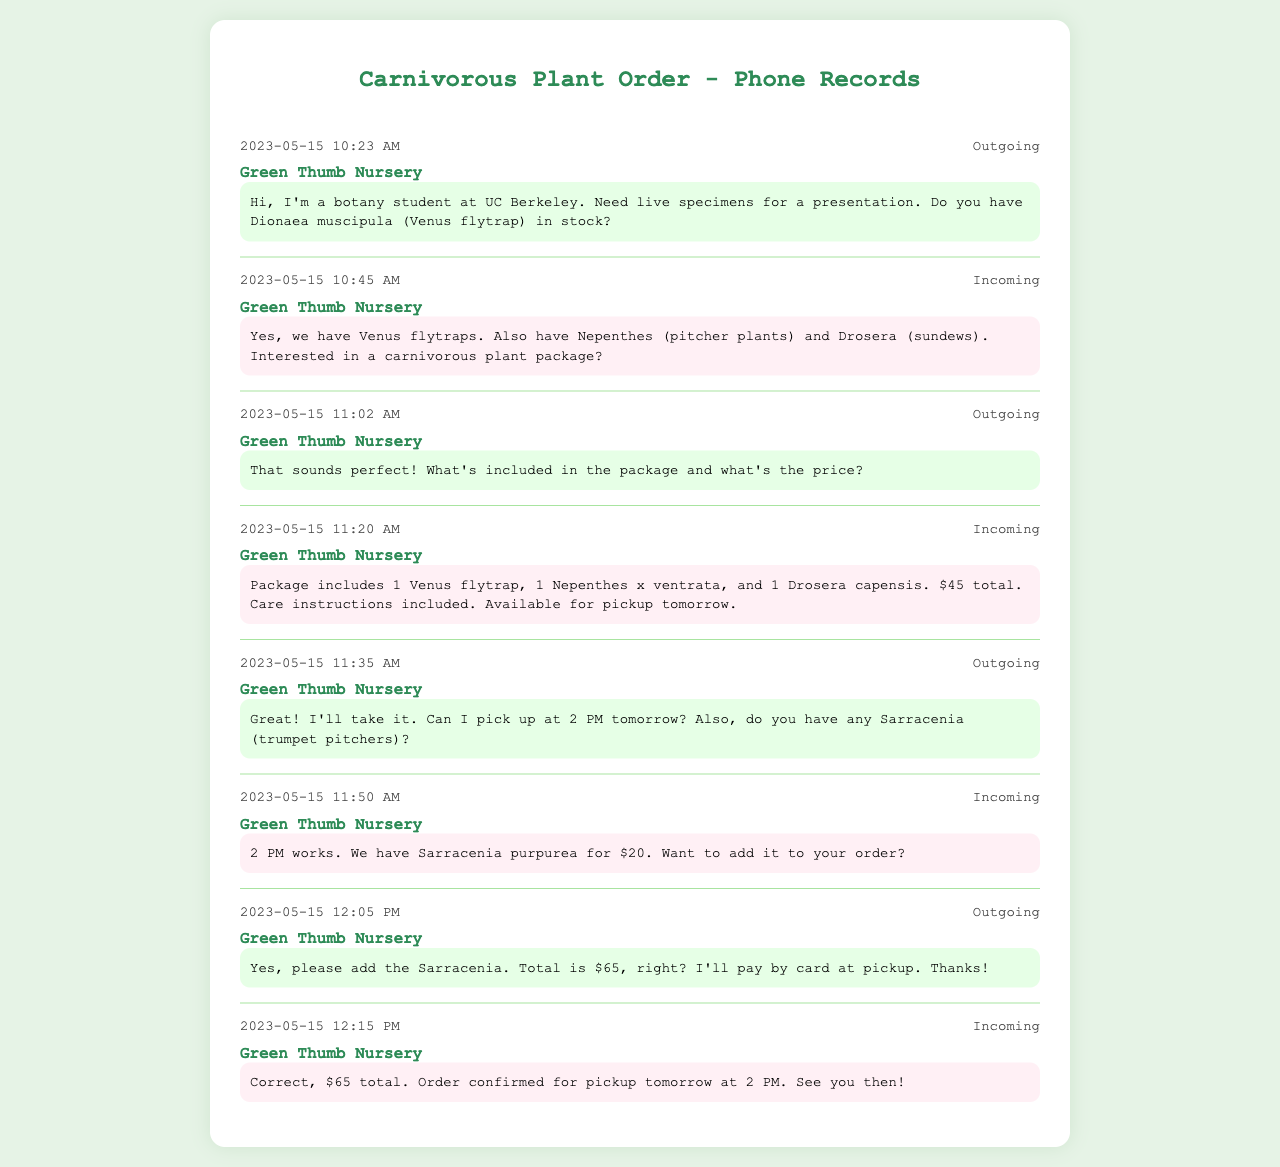what is the date of the order? The date of the order is found in the first message, which states it is on May 15, 2023.
Answer: May 15, 2023 what type of plant was initially inquired about? The initial inquiry was specifically about Dionaea muscipula, commonly known as the Venus flytrap.
Answer: Venus flytrap how much did the complete order cost? The complete order includes various plants and totals $65, as confirmed in the final message.
Answer: $65 what is included in the carnivorous plant package? The package consists of 1 Venus flytrap, 1 Nepenthes x ventrata, and 1 Drosera capensis as detailed in the corresponding message.
Answer: 1 Venus flytrap, 1 Nepenthes x ventrata, and 1 Drosera capensis what time is the pickup scheduled for? The pickup time is mentioned in the outgoing message where it asks for a 2 PM pickup.
Answer: 2 PM who is the sender of the first message? The first message is sent by a botany student from UC Berkeley, as introduced in the document.
Answer: botany student at UC Berkeley which plant was offered for an additional purchase? The message mentions Sarracenia purpurea as an option for an additional purchase.
Answer: Sarracenia purpurea what instructions are included with the package? Care instructions for the plants are mentioned as included in the package.
Answer: Care instructions 